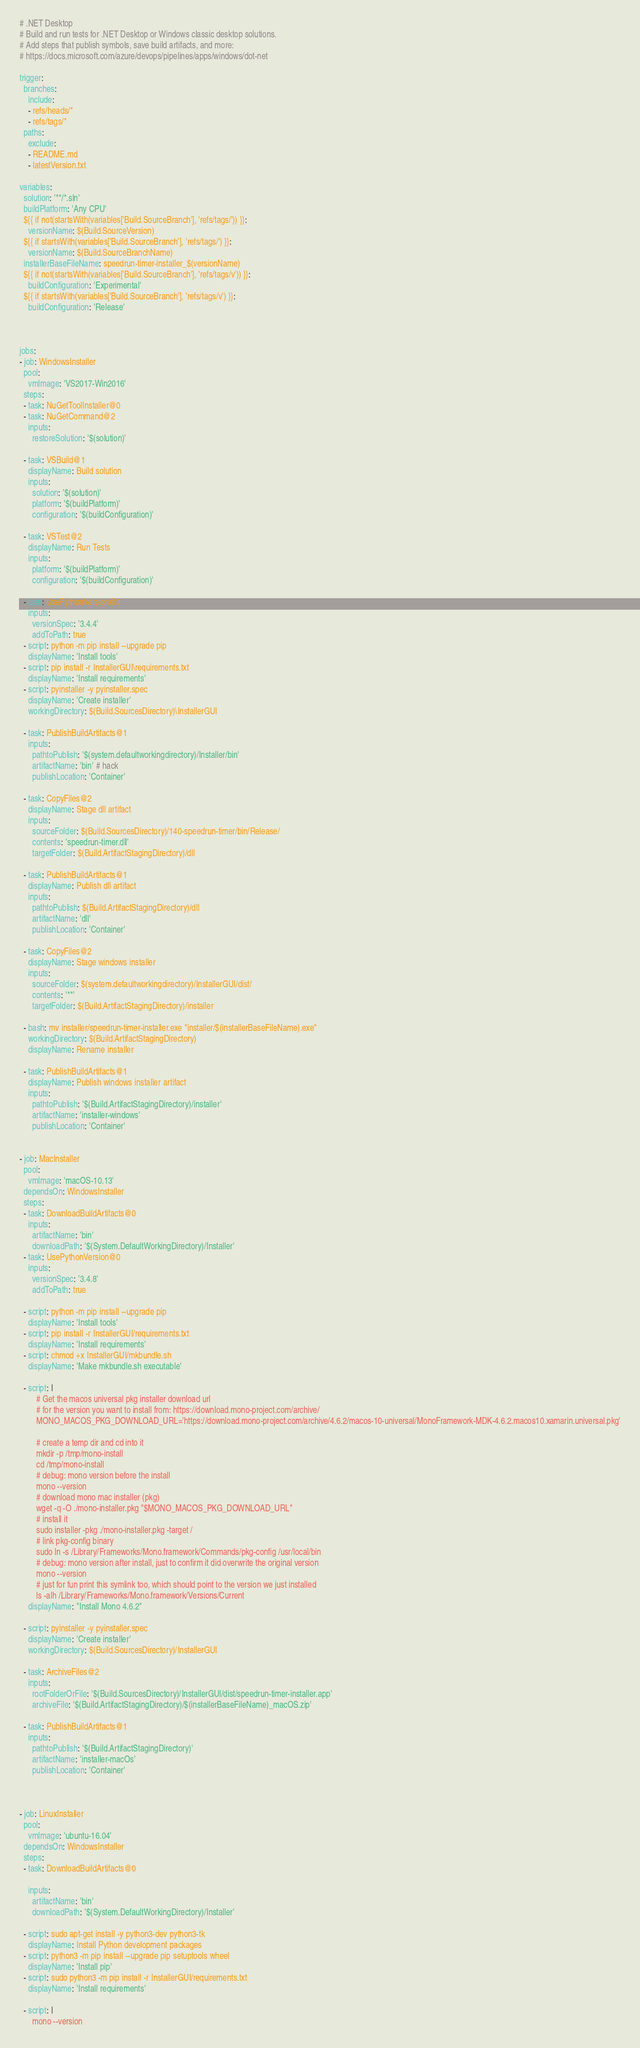Convert code to text. <code><loc_0><loc_0><loc_500><loc_500><_YAML_># .NET Desktop
# Build and run tests for .NET Desktop or Windows classic desktop solutions.
# Add steps that publish symbols, save build artifacts, and more:
# https://docs.microsoft.com/azure/devops/pipelines/apps/windows/dot-net

trigger:
  branches:
    include:
    - refs/heads/*
    - refs/tags/*
  paths:
    exclude:
    - README.md
    - latestVersion.txt

variables:
  solution: '**/*.sln'
  buildPlatform: 'Any CPU'
  ${{ if not(startsWith(variables['Build.SourceBranch'], 'refs/tags/')) }}:
    versionName: $(Build.SourceVersion)
  ${{ if startsWith(variables['Build.SourceBranch'], 'refs/tags/') }}:
    versionName: $(Build.SourceBranchName)
  installerBaseFileName: speedrun-timer-installer_$(versionName)
  ${{ if not(startsWith(variables['Build.SourceBranch'], 'refs/tags/v')) }}:
    buildConfiguration: 'Experimental'
  ${{ if startsWith(variables['Build.SourceBranch'], 'refs/tags/v') }}:
    buildConfiguration: 'Release'



jobs:
- job: WindowsInstaller
  pool:
    vmImage: 'VS2017-Win2016'
  steps:
  - task: NuGetToolInstaller@0
  - task: NuGetCommand@2
    inputs:
      restoreSolution: '$(solution)'

  - task: VSBuild@1
    displayName: Build solution
    inputs:
      solution: '$(solution)'
      platform: '$(buildPlatform)'
      configuration: '$(buildConfiguration)'

  - task: VSTest@2
    displayName: Run Tests
    inputs:
      platform: '$(buildPlatform)'
      configuration: '$(buildConfiguration)'

  - task: UsePythonVersion@0
    inputs:
      versionSpec: '3.4.4'
      addToPath: true
  - script: python -m pip install --upgrade pip
    displayName: 'Install tools'
  - script: pip install -r InstallerGUI\requirements.txt
    displayName: 'Install requirements'
  - script: pyinstaller -y pyinstaller.spec
    displayName: 'Create installer'
    workingDirectory: $(Build.SourcesDirectory)\InstallerGUI

  - task: PublishBuildArtifacts@1
    inputs:
      pathtoPublish: '$(system.defaultworkingdirectory)/Installer/bin'
      artifactName: 'bin' # hack
      publishLocation: 'Container'

  - task: CopyFiles@2
    displayName: Stage dll artifact
    inputs:
      sourceFolder: $(Build.SourcesDirectory)/140-speedrun-timer/bin/Release/
      contents: 'speedrun-timer.dll'
      targetFolder: $(Build.ArtifactStagingDirectory)/dll

  - task: PublishBuildArtifacts@1
    displayName: Publish dll artifact
    inputs:
      pathtoPublish: $(Build.ArtifactStagingDirectory)/dll
      artifactName: 'dll'
      publishLocation: 'Container'

  - task: CopyFiles@2
    displayName: Stage windows installer
    inputs:
      sourceFolder: $(system.defaultworkingdirectory)/InstallerGUI/dist/
      contents: '**'
      targetFolder: $(Build.ArtifactStagingDirectory)/installer

  - bash: mv installer/speedrun-timer-installer.exe "installer/$(installerBaseFileName).exe"
    workingDirectory: $(Build.ArtifactStagingDirectory)
    displayName: Rename installer

  - task: PublishBuildArtifacts@1
    displayName: Publish windows installer artifact
    inputs:
      pathtoPublish: '$(Build.ArtifactStagingDirectory)/installer'
      artifactName: 'installer-windows'
      publishLocation: 'Container'


- job: MacInstaller
  pool:
    vmImage: 'macOS-10.13'
  dependsOn: WindowsInstaller
  steps:
  - task: DownloadBuildArtifacts@0
    inputs:
      artifactName: 'bin'
      downloadPath: '$(System.DefaultWorkingDirectory)/Installer'
  - task: UsePythonVersion@0
    inputs:
      versionSpec: '3.4.8'
      addToPath: true

  - script: python -m pip install --upgrade pip
    displayName: 'Install tools'
  - script: pip install -r InstallerGUI/requirements.txt
    displayName: 'Install requirements'
  - script: chmod +x InstallerGUI/mkbundle.sh
    displayName: 'Make mkbundle.sh executable'

  - script: |
        # Get the macos universal pkg installer download url
        # for the version you want to install from: https://download.mono-project.com/archive/
        MONO_MACOS_PKG_DOWNLOAD_URL='https://download.mono-project.com/archive/4.6.2/macos-10-universal/MonoFramework-MDK-4.6.2.macos10.xamarin.universal.pkg'

        # create a temp dir and cd into it
        mkdir -p /tmp/mono-install
        cd /tmp/mono-install
        # debug: mono version before the install
        mono --version
        # download mono mac installer (pkg)
        wget -q -O ./mono-installer.pkg "$MONO_MACOS_PKG_DOWNLOAD_URL"
        # install it
        sudo installer -pkg ./mono-installer.pkg -target /
        # link pkg-config binary
        sudo ln -s /Library/Frameworks/Mono.framework/Commands/pkg-config /usr/local/bin
        # debug: mono version after install, just to confirm it did overwrite the original version
        mono --version
        # just for fun print this symlink too, which should point to the version we just installed
        ls -alh /Library/Frameworks/Mono.framework/Versions/Current
    displayName: "Install Mono 4.6.2"

  - script: pyinstaller -y pyinstaller.spec
    displayName: 'Create installer'
    workingDirectory: $(Build.SourcesDirectory)/InstallerGUI

  - task: ArchiveFiles@2
    inputs:
      rootFolderOrFile: '$(Build.SourcesDirectory)/InstallerGUI/dist/speedrun-timer-installer.app'
      archiveFile: '$(Build.ArtifactStagingDirectory)/$(installerBaseFileName)_macOS.zip'

  - task: PublishBuildArtifacts@1
    inputs:
      pathtoPublish: '$(Build.ArtifactStagingDirectory)'
      artifactName: 'installer-macOs'
      publishLocation: 'Container'



- job: LinuxInstaller
  pool:
    vmImage: 'ubuntu-16.04'
  dependsOn: WindowsInstaller
  steps:
  - task: DownloadBuildArtifacts@0

    inputs:
      artifactName: 'bin'
      downloadPath: '$(System.DefaultWorkingDirectory)/Installer'

  - script: sudo apt-get install -y python3-dev python3-tk
    displayName: Install Python development packages
  - script: python3 -m pip install --upgrade pip setuptools wheel
    displayName: 'Install pip'
  - script: sudo python3 -m pip install -r InstallerGUI/requirements.txt
    displayName: 'Install requirements'

  - script: |
      mono --version</code> 